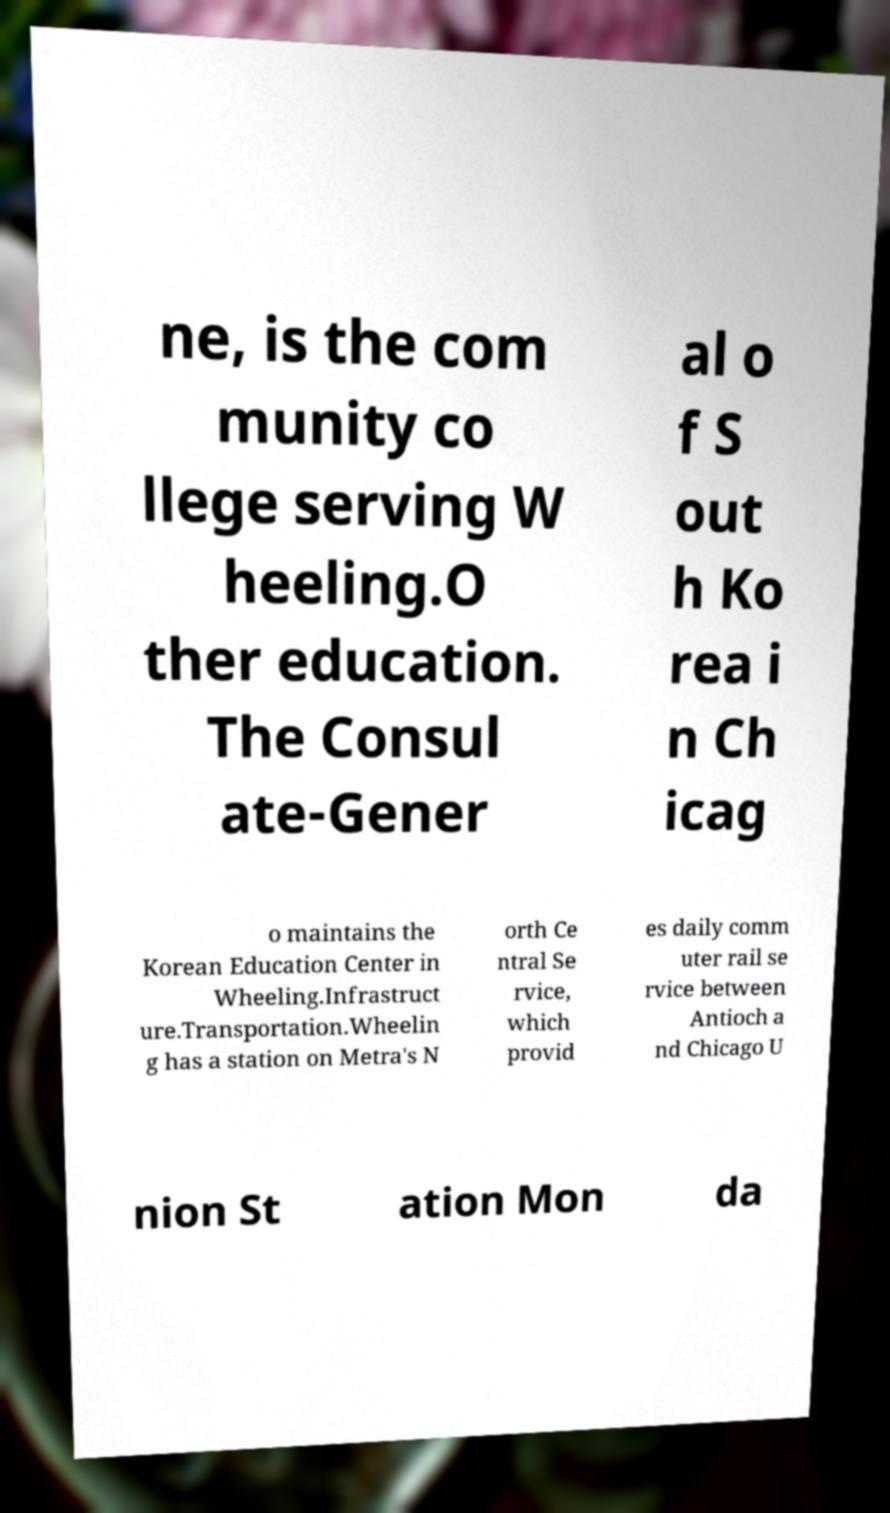For documentation purposes, I need the text within this image transcribed. Could you provide that? ne, is the com munity co llege serving W heeling.O ther education. The Consul ate-Gener al o f S out h Ko rea i n Ch icag o maintains the Korean Education Center in Wheeling.Infrastruct ure.Transportation.Wheelin g has a station on Metra's N orth Ce ntral Se rvice, which provid es daily comm uter rail se rvice between Antioch a nd Chicago U nion St ation Mon da 